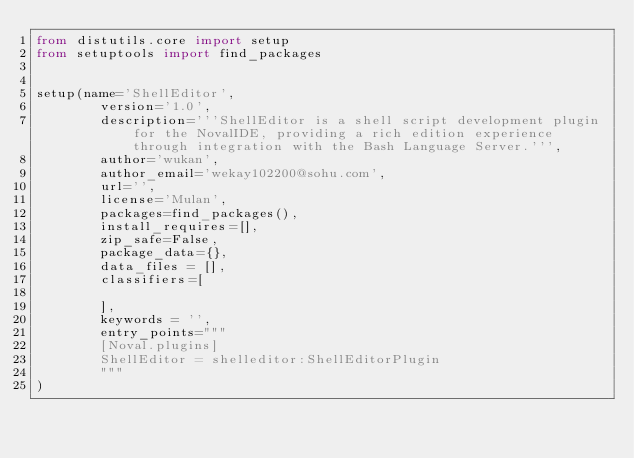<code> <loc_0><loc_0><loc_500><loc_500><_Python_>from distutils.core import setup
from setuptools import find_packages


setup(name='ShellEditor',
        version='1.0',
        description='''ShellEditor is a shell script development plugin for the NovalIDE, providing a rich edition experience through integration with the Bash Language Server.''',
        author='wukan',
        author_email='wekay102200@sohu.com',
        url='',
        license='Mulan',
        packages=find_packages(),
        install_requires=[],
        zip_safe=False,
        package_data={},
        data_files = [],
        classifiers=[
            
        ],
        keywords = '',
        entry_points="""
        [Noval.plugins]
        ShellEditor = shelleditor:ShellEditorPlugin
        """
)

</code> 